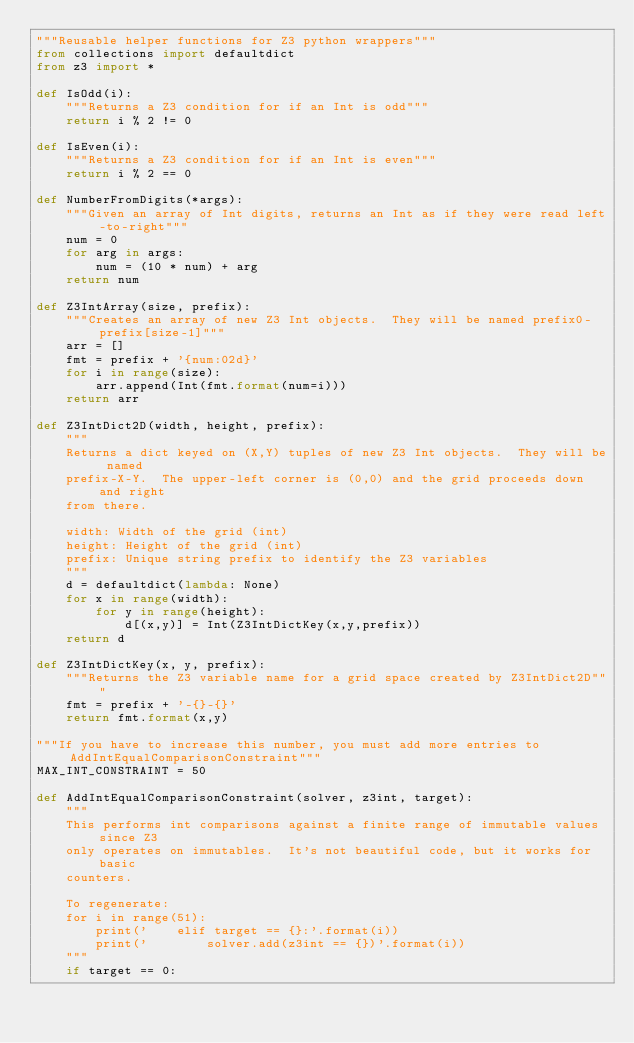<code> <loc_0><loc_0><loc_500><loc_500><_Python_>"""Reusable helper functions for Z3 python wrappers"""
from collections import defaultdict
from z3 import *

def IsOdd(i):
    """Returns a Z3 condition for if an Int is odd"""
    return i % 2 != 0

def IsEven(i):
    """Returns a Z3 condition for if an Int is even"""
    return i % 2 == 0

def NumberFromDigits(*args):
    """Given an array of Int digits, returns an Int as if they were read left-to-right"""
    num = 0
    for arg in args:
        num = (10 * num) + arg
    return num

def Z3IntArray(size, prefix):
    """Creates an array of new Z3 Int objects.  They will be named prefix0-prefix[size-1]"""
    arr = []
    fmt = prefix + '{num:02d}'
    for i in range(size):
        arr.append(Int(fmt.format(num=i)))
    return arr

def Z3IntDict2D(width, height, prefix):
    """
    Returns a dict keyed on (X,Y) tuples of new Z3 Int objects.  They will be named
    prefix-X-Y.  The upper-left corner is (0,0) and the grid proceeds down and right
    from there.

    width: Width of the grid (int)
    height: Height of the grid (int)
    prefix: Unique string prefix to identify the Z3 variables
    """
    d = defaultdict(lambda: None)
    for x in range(width):
        for y in range(height):
            d[(x,y)] = Int(Z3IntDictKey(x,y,prefix))
    return d

def Z3IntDictKey(x, y, prefix):
    """Returns the Z3 variable name for a grid space created by Z3IntDict2D"""
    fmt = prefix + '-{}-{}'
    return fmt.format(x,y)

"""If you have to increase this number, you must add more entries to AddIntEqualComparisonConstraint"""
MAX_INT_CONSTRAINT = 50

def AddIntEqualComparisonConstraint(solver, z3int, target):
    """
    This performs int comparisons against a finite range of immutable values since Z3
    only operates on immutables.  It's not beautiful code, but it works for basic
    counters.

    To regenerate:
    for i in range(51):
        print('    elif target == {}:'.format(i))
        print('        solver.add(z3int == {})'.format(i))
    """
    if target == 0:</code> 